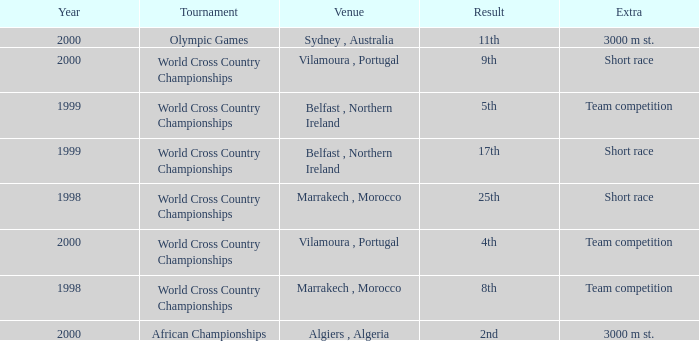Tell me the highest year for result of 9th 2000.0. 